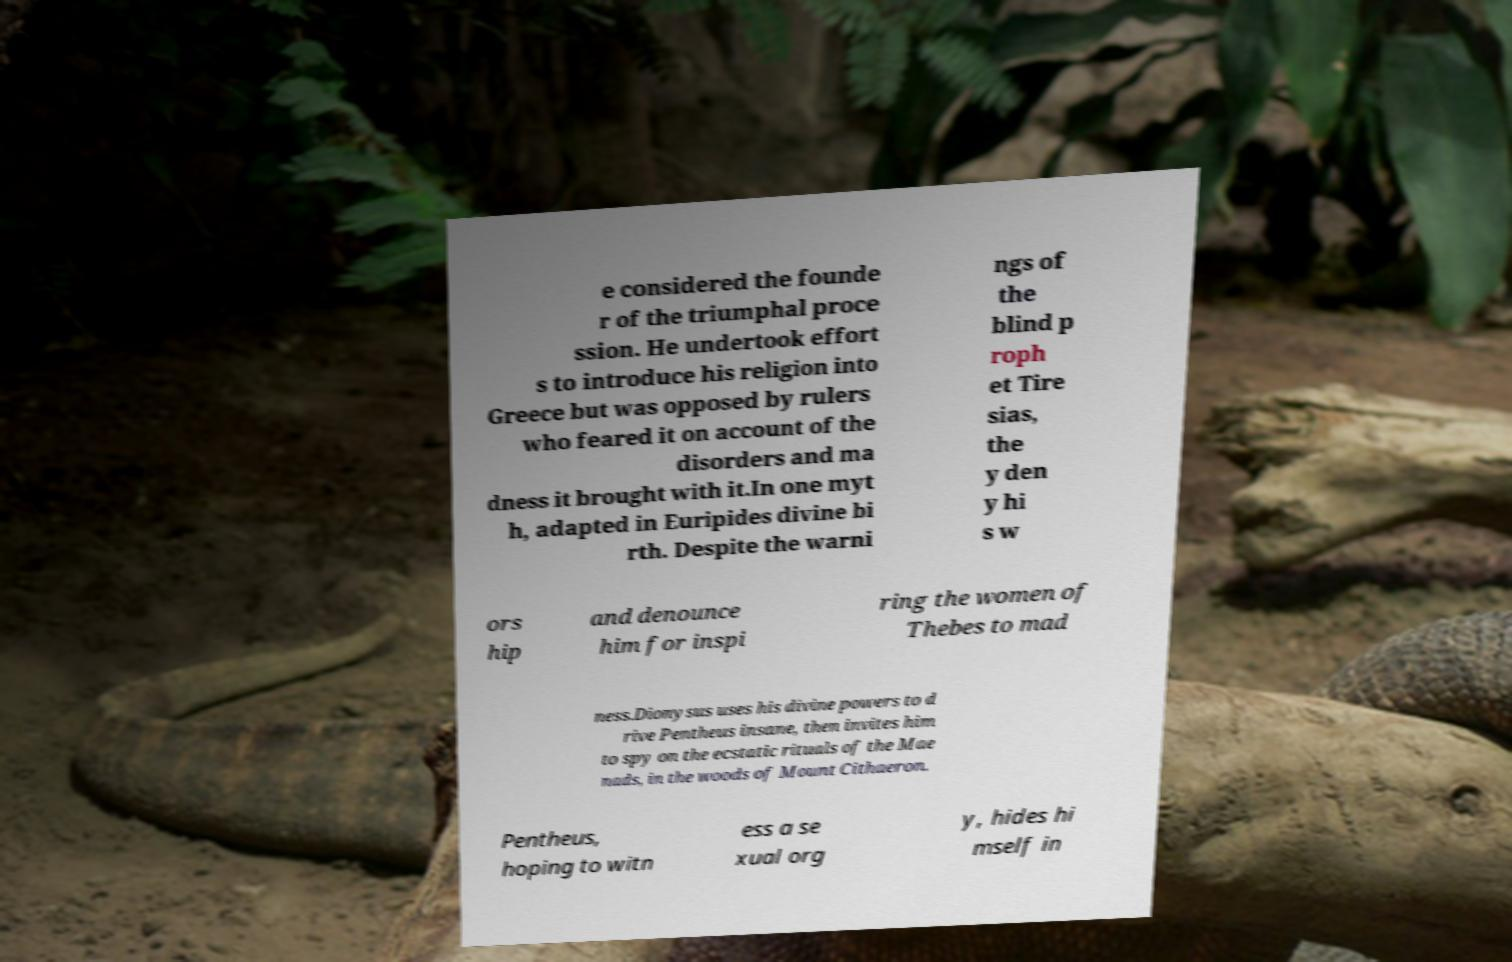Please identify and transcribe the text found in this image. e considered the founde r of the triumphal proce ssion. He undertook effort s to introduce his religion into Greece but was opposed by rulers who feared it on account of the disorders and ma dness it brought with it.In one myt h, adapted in Euripides divine bi rth. Despite the warni ngs of the blind p roph et Tire sias, the y den y hi s w ors hip and denounce him for inspi ring the women of Thebes to mad ness.Dionysus uses his divine powers to d rive Pentheus insane, then invites him to spy on the ecstatic rituals of the Mae nads, in the woods of Mount Cithaeron. Pentheus, hoping to witn ess a se xual org y, hides hi mself in 